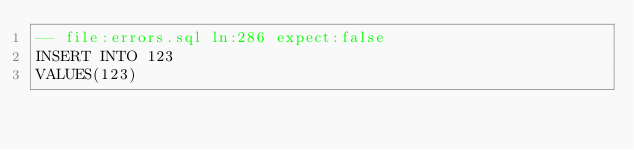<code> <loc_0><loc_0><loc_500><loc_500><_SQL_>-- file:errors.sql ln:286 expect:false
INSERT INTO 123
VALUES(123)
</code> 